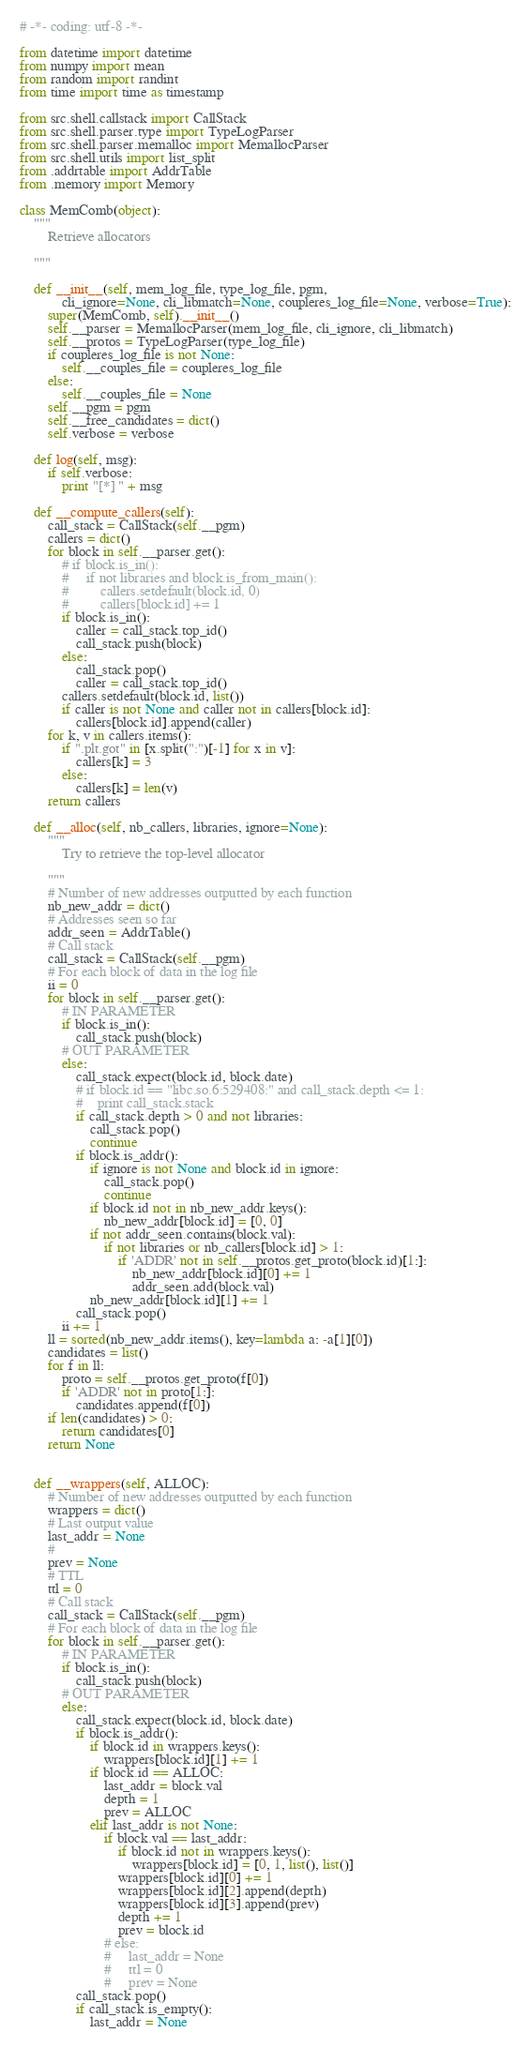<code> <loc_0><loc_0><loc_500><loc_500><_Python_># -*- coding: utf-8 -*-

from datetime import datetime
from numpy import mean 
from random import randint
from time import time as timestamp

from src.shell.callstack import CallStack
from src.shell.parser.type import TypeLogParser
from src.shell.parser.memalloc import MemallocParser
from src.shell.utils import list_split
from .addrtable import AddrTable
from .memory import Memory

class MemComb(object):
    """
        Retrieve allocators

    """

    def __init__(self, mem_log_file, type_log_file, pgm,
            cli_ignore=None, cli_libmatch=None, coupleres_log_file=None, verbose=True):
        super(MemComb, self).__init__()
        self.__parser = MemallocParser(mem_log_file, cli_ignore, cli_libmatch)
        self.__protos = TypeLogParser(type_log_file)
        if coupleres_log_file is not None:
            self.__couples_file = coupleres_log_file
        else:
            self.__couples_file = None
        self.__pgm = pgm
        self.__free_candidates = dict()
        self.verbose = verbose

    def log(self, msg):
        if self.verbose:
            print "[*] " + msg

    def __compute_callers(self):
        call_stack = CallStack(self.__pgm)
        callers = dict()
        for block in self.__parser.get():
            # if block.is_in():
            #     if not libraries and block.is_from_main():
            #         callers.setdefault(block.id, 0)
            #         callers[block.id] += 1
            if block.is_in():
                caller = call_stack.top_id()
                call_stack.push(block)
            else:
                call_stack.pop()
                caller = call_stack.top_id()
            callers.setdefault(block.id, list())
            if caller is not None and caller not in callers[block.id]:
                callers[block.id].append(caller)
        for k, v in callers.items():
            if ".plt.got" in [x.split(":")[-1] for x in v]:
                callers[k] = 3
            else:
                callers[k] = len(v)
        return callers

    def __alloc(self, nb_callers, libraries, ignore=None):
        """
            Try to retrieve the top-level allocator

        """
        # Number of new addresses outputted by each function
        nb_new_addr = dict()
        # Addresses seen so far
        addr_seen = AddrTable()
        # Call stack
        call_stack = CallStack(self.__pgm)
        # For each block of data in the log file
        ii = 0
        for block in self.__parser.get():
            # IN PARAMETER
            if block.is_in():
                call_stack.push(block)
            # OUT PARAMETER
            else:
                call_stack.expect(block.id, block.date)
                # if block.id == "libc.so.6:529408:" and call_stack.depth <= 1:
                #    print call_stack.stack
                if call_stack.depth > 0 and not libraries:
                    call_stack.pop()
                    continue
                if block.is_addr():
                    if ignore is not None and block.id in ignore:
                        call_stack.pop()
                        continue
                    if block.id not in nb_new_addr.keys():
                        nb_new_addr[block.id] = [0, 0]
                    if not addr_seen.contains(block.val): 
                        if not libraries or nb_callers[block.id] > 1:
                            if 'ADDR' not in self.__protos.get_proto(block.id)[1:]:
                                nb_new_addr[block.id][0] += 1
                                addr_seen.add(block.val)
                    nb_new_addr[block.id][1] += 1
                call_stack.pop()
            ii += 1
        ll = sorted(nb_new_addr.items(), key=lambda a: -a[1][0])
        candidates = list()
        for f in ll:
            proto = self.__protos.get_proto(f[0])
            if 'ADDR' not in proto[1:]:
                candidates.append(f[0])
        if len(candidates) > 0:
            return candidates[0]
        return None


    def __wrappers(self, ALLOC):
        # Number of new addresses outputted by each function
        wrappers = dict()
        # Last output value
        last_addr = None
        #
        prev = None
        # TTL
        ttl = 0
        # Call stack
        call_stack = CallStack(self.__pgm)
        # For each block of data in the log file
        for block in self.__parser.get():
            # IN PARAMETER
            if block.is_in():
                call_stack.push(block)
            # OUT PARAMETER
            else:
                call_stack.expect(block.id, block.date)
                if block.is_addr():
                    if block.id in wrappers.keys():
                        wrappers[block.id][1] += 1
                    if block.id == ALLOC:
                        last_addr = block.val
                        depth = 1
                        prev = ALLOC
                    elif last_addr is not None:
                        if block.val == last_addr:
                            if block.id not in wrappers.keys():
                                wrappers[block.id] = [0, 1, list(), list()]
                            wrappers[block.id][0] += 1
                            wrappers[block.id][2].append(depth)
                            wrappers[block.id][3].append(prev)
                            depth += 1
                            prev = block.id
                        # else:
                        #     last_addr = None
                        #     ttl = 0
                        #     prev = None
                call_stack.pop()
                if call_stack.is_empty():
                    last_addr = None</code> 